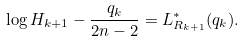Convert formula to latex. <formula><loc_0><loc_0><loc_500><loc_500>\log H _ { k + 1 } - \frac { q _ { k } } { 2 n - 2 } = L _ { R _ { k + 1 } } ^ { \ast } ( q _ { k } ) .</formula> 